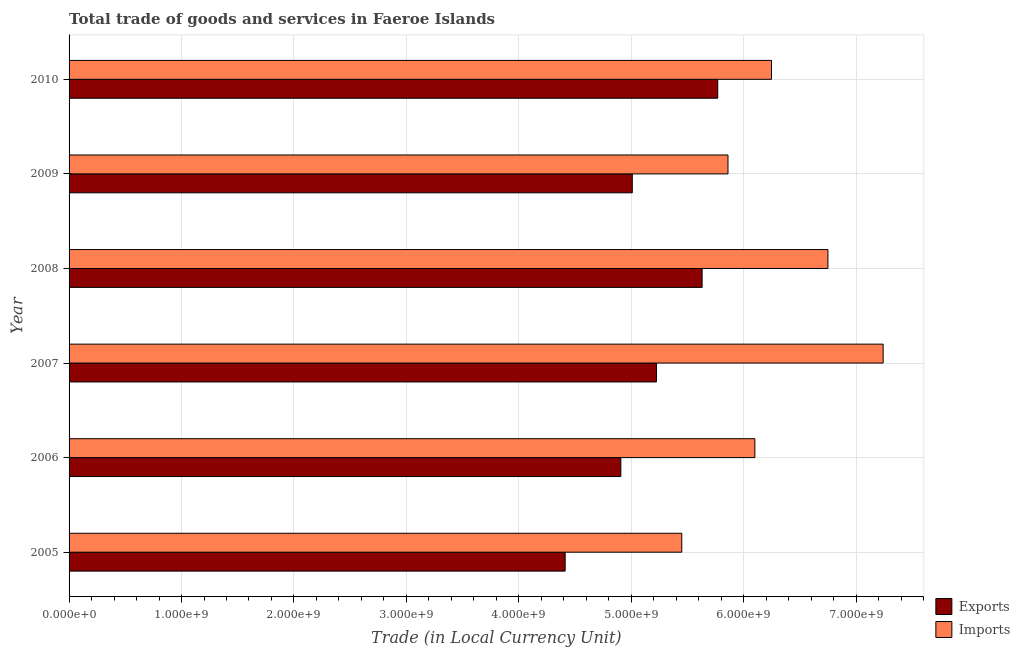How many groups of bars are there?
Provide a short and direct response. 6. Are the number of bars on each tick of the Y-axis equal?
Provide a succinct answer. Yes. How many bars are there on the 3rd tick from the top?
Keep it short and to the point. 2. How many bars are there on the 1st tick from the bottom?
Provide a succinct answer. 2. In how many cases, is the number of bars for a given year not equal to the number of legend labels?
Your response must be concise. 0. What is the export of goods and services in 2010?
Provide a short and direct response. 5.77e+09. Across all years, what is the maximum imports of goods and services?
Your answer should be very brief. 7.24e+09. Across all years, what is the minimum imports of goods and services?
Offer a very short reply. 5.45e+09. What is the total export of goods and services in the graph?
Keep it short and to the point. 3.10e+1. What is the difference between the imports of goods and services in 2006 and that in 2008?
Provide a succinct answer. -6.50e+08. What is the difference between the imports of goods and services in 2005 and the export of goods and services in 2010?
Make the answer very short. -3.20e+08. What is the average export of goods and services per year?
Provide a succinct answer. 5.16e+09. In the year 2007, what is the difference between the imports of goods and services and export of goods and services?
Your response must be concise. 2.02e+09. What is the ratio of the export of goods and services in 2005 to that in 2009?
Your answer should be compact. 0.88. What is the difference between the highest and the second highest export of goods and services?
Your response must be concise. 1.39e+08. What is the difference between the highest and the lowest export of goods and services?
Make the answer very short. 1.36e+09. In how many years, is the export of goods and services greater than the average export of goods and services taken over all years?
Offer a very short reply. 3. Is the sum of the imports of goods and services in 2006 and 2010 greater than the maximum export of goods and services across all years?
Your answer should be compact. Yes. What does the 1st bar from the top in 2005 represents?
Ensure brevity in your answer.  Imports. What does the 2nd bar from the bottom in 2009 represents?
Provide a short and direct response. Imports. How many bars are there?
Offer a very short reply. 12. How many years are there in the graph?
Give a very brief answer. 6. What is the difference between two consecutive major ticks on the X-axis?
Give a very brief answer. 1.00e+09. Are the values on the major ticks of X-axis written in scientific E-notation?
Make the answer very short. Yes. How many legend labels are there?
Offer a very short reply. 2. How are the legend labels stacked?
Ensure brevity in your answer.  Vertical. What is the title of the graph?
Your response must be concise. Total trade of goods and services in Faeroe Islands. Does "Enforce a contract" appear as one of the legend labels in the graph?
Offer a very short reply. No. What is the label or title of the X-axis?
Offer a very short reply. Trade (in Local Currency Unit). What is the Trade (in Local Currency Unit) of Exports in 2005?
Keep it short and to the point. 4.41e+09. What is the Trade (in Local Currency Unit) in Imports in 2005?
Provide a short and direct response. 5.45e+09. What is the Trade (in Local Currency Unit) of Exports in 2006?
Make the answer very short. 4.91e+09. What is the Trade (in Local Currency Unit) in Imports in 2006?
Your answer should be very brief. 6.10e+09. What is the Trade (in Local Currency Unit) in Exports in 2007?
Your response must be concise. 5.22e+09. What is the Trade (in Local Currency Unit) of Imports in 2007?
Provide a succinct answer. 7.24e+09. What is the Trade (in Local Currency Unit) in Exports in 2008?
Make the answer very short. 5.63e+09. What is the Trade (in Local Currency Unit) of Imports in 2008?
Make the answer very short. 6.75e+09. What is the Trade (in Local Currency Unit) of Exports in 2009?
Provide a succinct answer. 5.01e+09. What is the Trade (in Local Currency Unit) of Imports in 2009?
Ensure brevity in your answer.  5.86e+09. What is the Trade (in Local Currency Unit) in Exports in 2010?
Your response must be concise. 5.77e+09. What is the Trade (in Local Currency Unit) in Imports in 2010?
Provide a short and direct response. 6.25e+09. Across all years, what is the maximum Trade (in Local Currency Unit) in Exports?
Give a very brief answer. 5.77e+09. Across all years, what is the maximum Trade (in Local Currency Unit) in Imports?
Keep it short and to the point. 7.24e+09. Across all years, what is the minimum Trade (in Local Currency Unit) in Exports?
Offer a very short reply. 4.41e+09. Across all years, what is the minimum Trade (in Local Currency Unit) of Imports?
Offer a very short reply. 5.45e+09. What is the total Trade (in Local Currency Unit) of Exports in the graph?
Give a very brief answer. 3.10e+1. What is the total Trade (in Local Currency Unit) of Imports in the graph?
Offer a very short reply. 3.76e+1. What is the difference between the Trade (in Local Currency Unit) of Exports in 2005 and that in 2006?
Provide a succinct answer. -4.95e+08. What is the difference between the Trade (in Local Currency Unit) in Imports in 2005 and that in 2006?
Give a very brief answer. -6.50e+08. What is the difference between the Trade (in Local Currency Unit) of Exports in 2005 and that in 2007?
Make the answer very short. -8.12e+08. What is the difference between the Trade (in Local Currency Unit) of Imports in 2005 and that in 2007?
Offer a very short reply. -1.79e+09. What is the difference between the Trade (in Local Currency Unit) in Exports in 2005 and that in 2008?
Your response must be concise. -1.22e+09. What is the difference between the Trade (in Local Currency Unit) in Imports in 2005 and that in 2008?
Give a very brief answer. -1.30e+09. What is the difference between the Trade (in Local Currency Unit) of Exports in 2005 and that in 2009?
Keep it short and to the point. -5.97e+08. What is the difference between the Trade (in Local Currency Unit) in Imports in 2005 and that in 2009?
Make the answer very short. -4.11e+08. What is the difference between the Trade (in Local Currency Unit) of Exports in 2005 and that in 2010?
Ensure brevity in your answer.  -1.36e+09. What is the difference between the Trade (in Local Currency Unit) in Imports in 2005 and that in 2010?
Your answer should be compact. -7.98e+08. What is the difference between the Trade (in Local Currency Unit) of Exports in 2006 and that in 2007?
Provide a succinct answer. -3.17e+08. What is the difference between the Trade (in Local Currency Unit) of Imports in 2006 and that in 2007?
Your answer should be compact. -1.14e+09. What is the difference between the Trade (in Local Currency Unit) of Exports in 2006 and that in 2008?
Keep it short and to the point. -7.23e+08. What is the difference between the Trade (in Local Currency Unit) in Imports in 2006 and that in 2008?
Ensure brevity in your answer.  -6.50e+08. What is the difference between the Trade (in Local Currency Unit) in Exports in 2006 and that in 2009?
Give a very brief answer. -1.02e+08. What is the difference between the Trade (in Local Currency Unit) of Imports in 2006 and that in 2009?
Give a very brief answer. 2.39e+08. What is the difference between the Trade (in Local Currency Unit) of Exports in 2006 and that in 2010?
Offer a very short reply. -8.62e+08. What is the difference between the Trade (in Local Currency Unit) in Imports in 2006 and that in 2010?
Offer a terse response. -1.48e+08. What is the difference between the Trade (in Local Currency Unit) in Exports in 2007 and that in 2008?
Keep it short and to the point. -4.06e+08. What is the difference between the Trade (in Local Currency Unit) in Imports in 2007 and that in 2008?
Your answer should be compact. 4.91e+08. What is the difference between the Trade (in Local Currency Unit) in Exports in 2007 and that in 2009?
Offer a terse response. 2.15e+08. What is the difference between the Trade (in Local Currency Unit) in Imports in 2007 and that in 2009?
Offer a very short reply. 1.38e+09. What is the difference between the Trade (in Local Currency Unit) of Exports in 2007 and that in 2010?
Provide a succinct answer. -5.45e+08. What is the difference between the Trade (in Local Currency Unit) in Imports in 2007 and that in 2010?
Offer a very short reply. 9.93e+08. What is the difference between the Trade (in Local Currency Unit) in Exports in 2008 and that in 2009?
Give a very brief answer. 6.21e+08. What is the difference between the Trade (in Local Currency Unit) in Imports in 2008 and that in 2009?
Your answer should be compact. 8.89e+08. What is the difference between the Trade (in Local Currency Unit) in Exports in 2008 and that in 2010?
Make the answer very short. -1.39e+08. What is the difference between the Trade (in Local Currency Unit) of Imports in 2008 and that in 2010?
Keep it short and to the point. 5.02e+08. What is the difference between the Trade (in Local Currency Unit) in Exports in 2009 and that in 2010?
Give a very brief answer. -7.60e+08. What is the difference between the Trade (in Local Currency Unit) of Imports in 2009 and that in 2010?
Offer a terse response. -3.87e+08. What is the difference between the Trade (in Local Currency Unit) in Exports in 2005 and the Trade (in Local Currency Unit) in Imports in 2006?
Ensure brevity in your answer.  -1.69e+09. What is the difference between the Trade (in Local Currency Unit) in Exports in 2005 and the Trade (in Local Currency Unit) in Imports in 2007?
Provide a short and direct response. -2.83e+09. What is the difference between the Trade (in Local Currency Unit) of Exports in 2005 and the Trade (in Local Currency Unit) of Imports in 2008?
Your answer should be compact. -2.34e+09. What is the difference between the Trade (in Local Currency Unit) of Exports in 2005 and the Trade (in Local Currency Unit) of Imports in 2009?
Your answer should be very brief. -1.45e+09. What is the difference between the Trade (in Local Currency Unit) of Exports in 2005 and the Trade (in Local Currency Unit) of Imports in 2010?
Your response must be concise. -1.84e+09. What is the difference between the Trade (in Local Currency Unit) of Exports in 2006 and the Trade (in Local Currency Unit) of Imports in 2007?
Your answer should be compact. -2.33e+09. What is the difference between the Trade (in Local Currency Unit) of Exports in 2006 and the Trade (in Local Currency Unit) of Imports in 2008?
Offer a terse response. -1.84e+09. What is the difference between the Trade (in Local Currency Unit) of Exports in 2006 and the Trade (in Local Currency Unit) of Imports in 2009?
Offer a terse response. -9.53e+08. What is the difference between the Trade (in Local Currency Unit) of Exports in 2006 and the Trade (in Local Currency Unit) of Imports in 2010?
Offer a terse response. -1.34e+09. What is the difference between the Trade (in Local Currency Unit) of Exports in 2007 and the Trade (in Local Currency Unit) of Imports in 2008?
Make the answer very short. -1.52e+09. What is the difference between the Trade (in Local Currency Unit) in Exports in 2007 and the Trade (in Local Currency Unit) in Imports in 2009?
Provide a short and direct response. -6.36e+08. What is the difference between the Trade (in Local Currency Unit) in Exports in 2007 and the Trade (in Local Currency Unit) in Imports in 2010?
Make the answer very short. -1.02e+09. What is the difference between the Trade (in Local Currency Unit) of Exports in 2008 and the Trade (in Local Currency Unit) of Imports in 2009?
Ensure brevity in your answer.  -2.30e+08. What is the difference between the Trade (in Local Currency Unit) in Exports in 2008 and the Trade (in Local Currency Unit) in Imports in 2010?
Keep it short and to the point. -6.17e+08. What is the difference between the Trade (in Local Currency Unit) in Exports in 2009 and the Trade (in Local Currency Unit) in Imports in 2010?
Provide a short and direct response. -1.24e+09. What is the average Trade (in Local Currency Unit) in Exports per year?
Your answer should be compact. 5.16e+09. What is the average Trade (in Local Currency Unit) in Imports per year?
Provide a short and direct response. 6.27e+09. In the year 2005, what is the difference between the Trade (in Local Currency Unit) in Exports and Trade (in Local Currency Unit) in Imports?
Your response must be concise. -1.04e+09. In the year 2006, what is the difference between the Trade (in Local Currency Unit) of Exports and Trade (in Local Currency Unit) of Imports?
Provide a short and direct response. -1.19e+09. In the year 2007, what is the difference between the Trade (in Local Currency Unit) of Exports and Trade (in Local Currency Unit) of Imports?
Your response must be concise. -2.02e+09. In the year 2008, what is the difference between the Trade (in Local Currency Unit) of Exports and Trade (in Local Currency Unit) of Imports?
Your response must be concise. -1.12e+09. In the year 2009, what is the difference between the Trade (in Local Currency Unit) in Exports and Trade (in Local Currency Unit) in Imports?
Give a very brief answer. -8.51e+08. In the year 2010, what is the difference between the Trade (in Local Currency Unit) in Exports and Trade (in Local Currency Unit) in Imports?
Ensure brevity in your answer.  -4.78e+08. What is the ratio of the Trade (in Local Currency Unit) in Exports in 2005 to that in 2006?
Offer a very short reply. 0.9. What is the ratio of the Trade (in Local Currency Unit) of Imports in 2005 to that in 2006?
Your answer should be very brief. 0.89. What is the ratio of the Trade (in Local Currency Unit) in Exports in 2005 to that in 2007?
Your answer should be very brief. 0.84. What is the ratio of the Trade (in Local Currency Unit) of Imports in 2005 to that in 2007?
Your response must be concise. 0.75. What is the ratio of the Trade (in Local Currency Unit) of Exports in 2005 to that in 2008?
Provide a succinct answer. 0.78. What is the ratio of the Trade (in Local Currency Unit) in Imports in 2005 to that in 2008?
Offer a terse response. 0.81. What is the ratio of the Trade (in Local Currency Unit) in Exports in 2005 to that in 2009?
Provide a short and direct response. 0.88. What is the ratio of the Trade (in Local Currency Unit) in Imports in 2005 to that in 2009?
Make the answer very short. 0.93. What is the ratio of the Trade (in Local Currency Unit) in Exports in 2005 to that in 2010?
Your response must be concise. 0.76. What is the ratio of the Trade (in Local Currency Unit) of Imports in 2005 to that in 2010?
Offer a very short reply. 0.87. What is the ratio of the Trade (in Local Currency Unit) in Exports in 2006 to that in 2007?
Offer a terse response. 0.94. What is the ratio of the Trade (in Local Currency Unit) in Imports in 2006 to that in 2007?
Make the answer very short. 0.84. What is the ratio of the Trade (in Local Currency Unit) of Exports in 2006 to that in 2008?
Make the answer very short. 0.87. What is the ratio of the Trade (in Local Currency Unit) in Imports in 2006 to that in 2008?
Your answer should be compact. 0.9. What is the ratio of the Trade (in Local Currency Unit) in Exports in 2006 to that in 2009?
Ensure brevity in your answer.  0.98. What is the ratio of the Trade (in Local Currency Unit) of Imports in 2006 to that in 2009?
Your answer should be very brief. 1.04. What is the ratio of the Trade (in Local Currency Unit) of Exports in 2006 to that in 2010?
Your answer should be compact. 0.85. What is the ratio of the Trade (in Local Currency Unit) of Imports in 2006 to that in 2010?
Give a very brief answer. 0.98. What is the ratio of the Trade (in Local Currency Unit) in Exports in 2007 to that in 2008?
Offer a terse response. 0.93. What is the ratio of the Trade (in Local Currency Unit) of Imports in 2007 to that in 2008?
Your answer should be compact. 1.07. What is the ratio of the Trade (in Local Currency Unit) in Exports in 2007 to that in 2009?
Provide a succinct answer. 1.04. What is the ratio of the Trade (in Local Currency Unit) of Imports in 2007 to that in 2009?
Your response must be concise. 1.24. What is the ratio of the Trade (in Local Currency Unit) in Exports in 2007 to that in 2010?
Provide a short and direct response. 0.91. What is the ratio of the Trade (in Local Currency Unit) of Imports in 2007 to that in 2010?
Give a very brief answer. 1.16. What is the ratio of the Trade (in Local Currency Unit) in Exports in 2008 to that in 2009?
Offer a very short reply. 1.12. What is the ratio of the Trade (in Local Currency Unit) of Imports in 2008 to that in 2009?
Make the answer very short. 1.15. What is the ratio of the Trade (in Local Currency Unit) of Exports in 2008 to that in 2010?
Your answer should be compact. 0.98. What is the ratio of the Trade (in Local Currency Unit) of Imports in 2008 to that in 2010?
Provide a short and direct response. 1.08. What is the ratio of the Trade (in Local Currency Unit) in Exports in 2009 to that in 2010?
Ensure brevity in your answer.  0.87. What is the ratio of the Trade (in Local Currency Unit) of Imports in 2009 to that in 2010?
Your response must be concise. 0.94. What is the difference between the highest and the second highest Trade (in Local Currency Unit) of Exports?
Offer a terse response. 1.39e+08. What is the difference between the highest and the second highest Trade (in Local Currency Unit) of Imports?
Ensure brevity in your answer.  4.91e+08. What is the difference between the highest and the lowest Trade (in Local Currency Unit) of Exports?
Your answer should be very brief. 1.36e+09. What is the difference between the highest and the lowest Trade (in Local Currency Unit) in Imports?
Keep it short and to the point. 1.79e+09. 